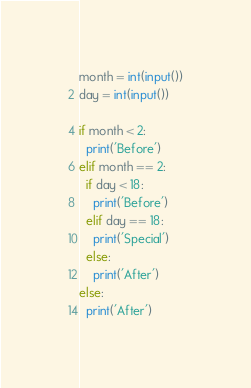<code> <loc_0><loc_0><loc_500><loc_500><_Python_>month = int(input())
day = int(input())

if month < 2:
  print('Before')
elif month == 2:
  if day < 18:
    print('Before')
  elif day == 18:
    print('Special')
  else:
    print('After')
else:
  print('After')</code> 